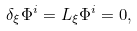<formula> <loc_0><loc_0><loc_500><loc_500>\delta _ { \xi } \Phi ^ { i } = L _ { \xi } \Phi ^ { i } = 0 ,</formula> 